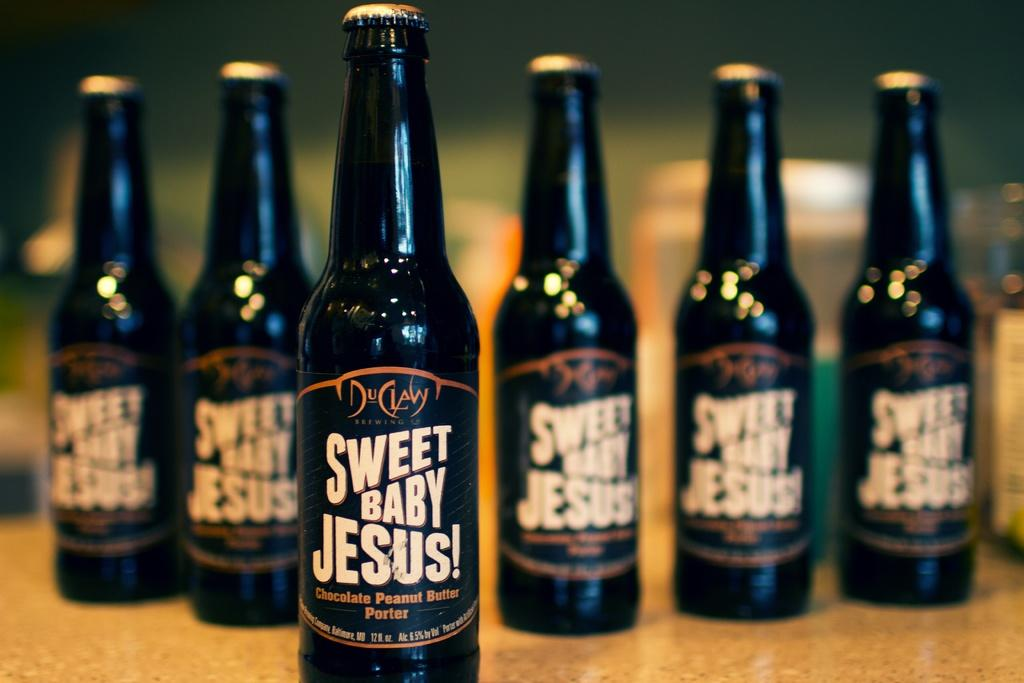Provide a one-sentence caption for the provided image. Six bottles of Sweet Baby Jesus! beer in a line with one out front. 